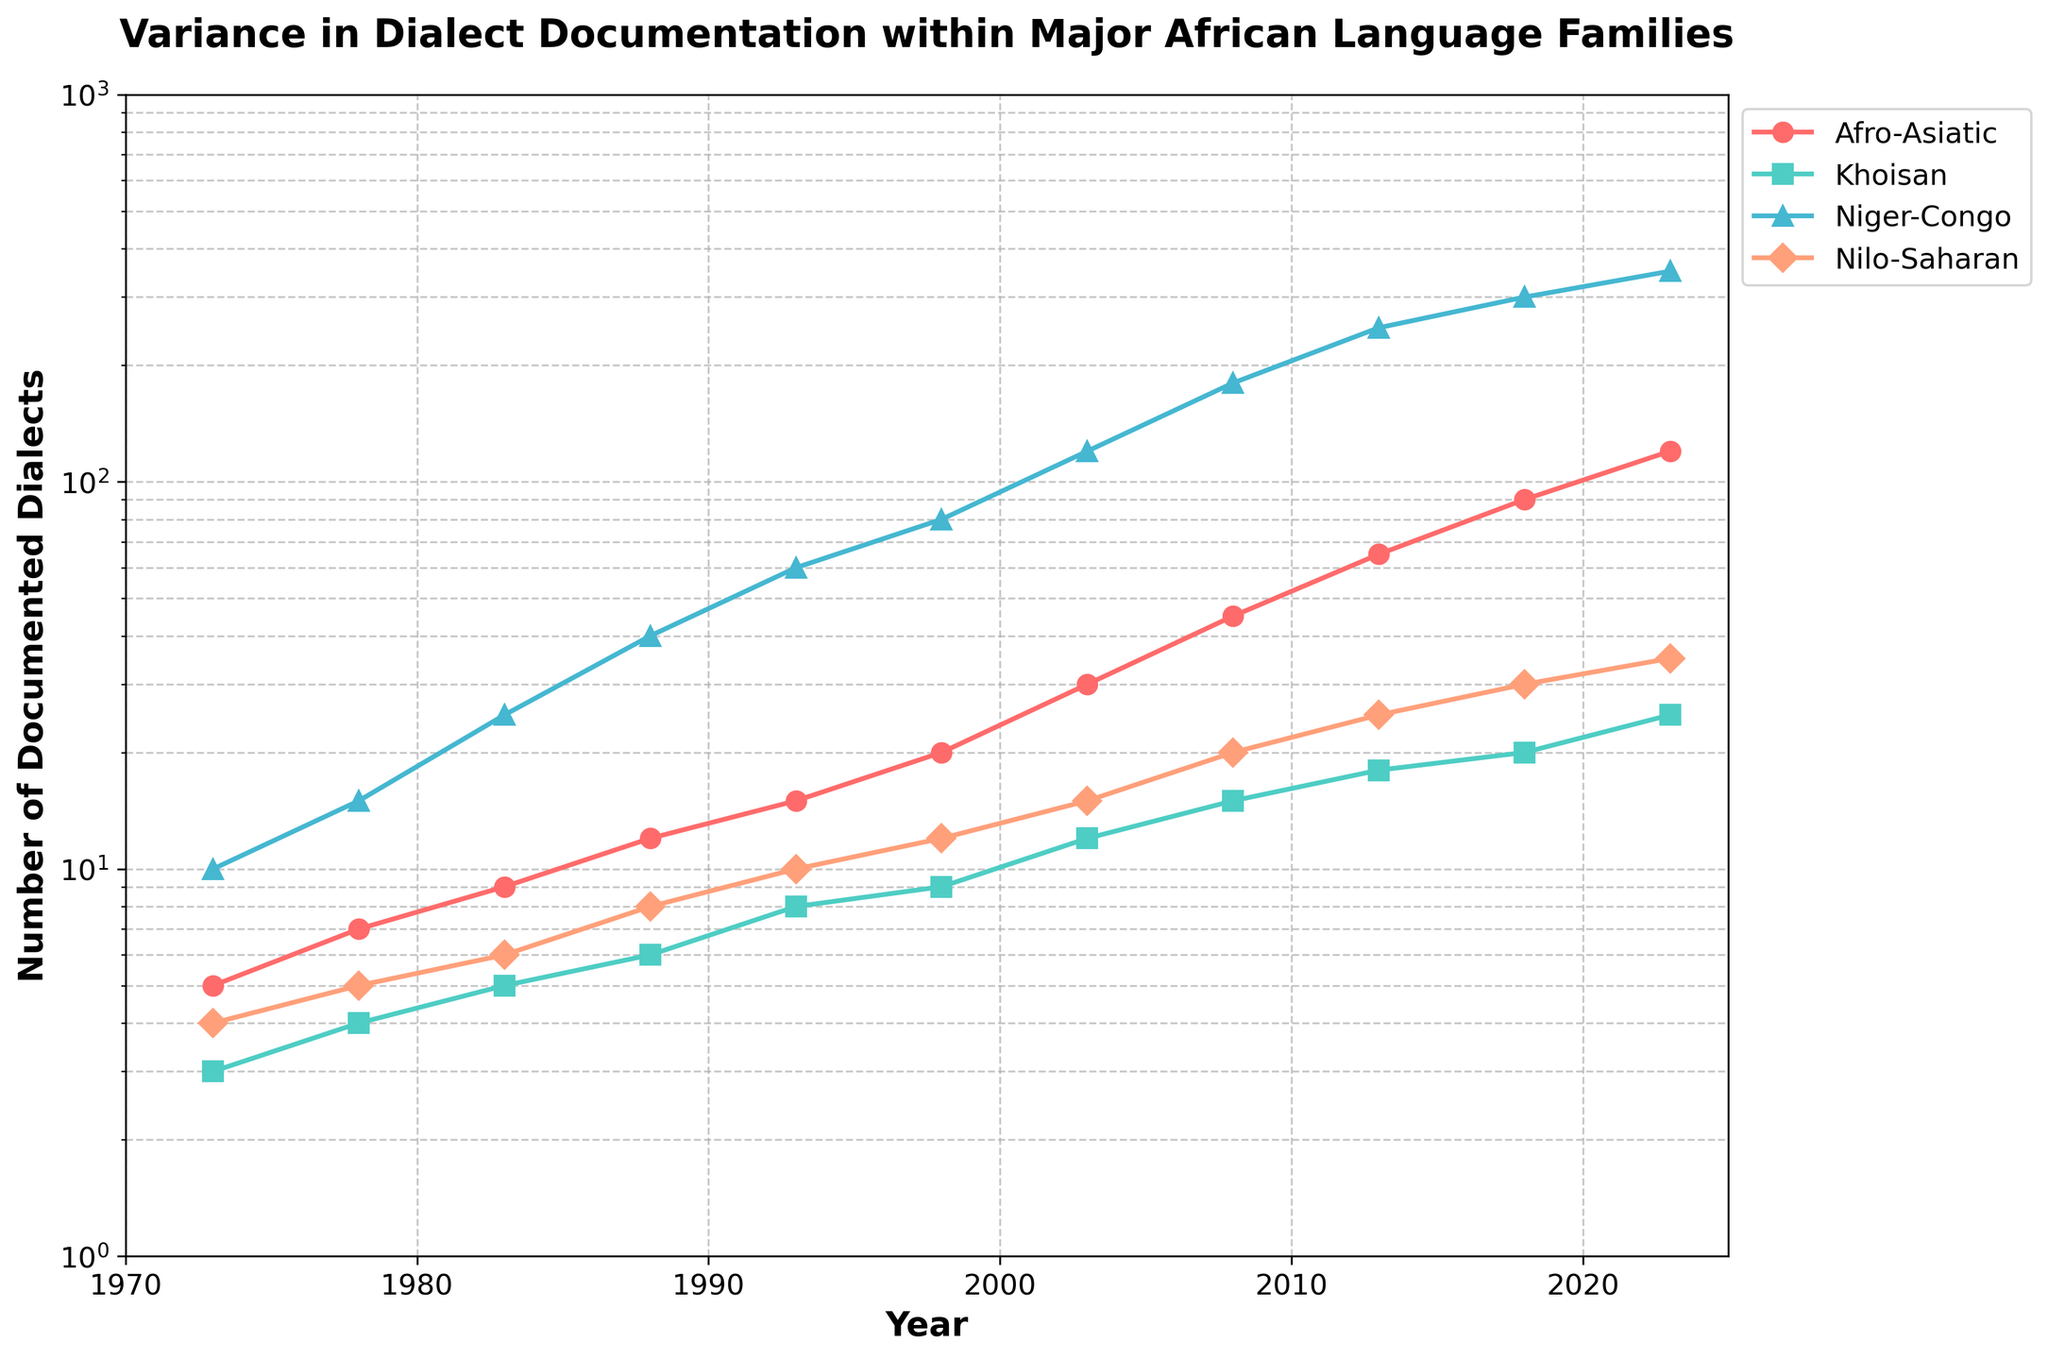What is the title of the figure? The title is displayed at the top center of the figure in bold font.
Answer: Variance in Dialect Documentation within Major African Language Families Which language family had the fewest documented dialects in 1973? By looking at the data points for the year 1973, the dialect counts for each language family are shown. The least documented is Khoisan with 3 dialects.
Answer: Khoisan How many documented dialects did the Niger-Congo family have in 2008? We look at the data point for the Niger-Congo family specifically in the year 2008. The documented dialects count is 180.
Answer: 180 What is the range of documented dialects in the Nilo-Saharan family from 1973 to 2023? The range is found by subtracting the minimum value from the maximum value in the Nilo-Saharan family dataset. From the data, 35 (2023) - 4 (1973) = 31.
Answer: 31 Which language family showed the steepest growth in documented dialects over the 50 years? By examining the slopes of the lines, the Niger-Congo family shows the sharpest increase from 10 in 1973 to 350 in 2023.
Answer: Niger-Congo In what years did the Afro-Asiatic language family have over 50 documented dialects? Checking the data points for the Afro-Asiatic family, the number surpasses 50 starting from the year 2013 onward.
Answer: 2013, 2018, 2023 What is the average number of documented dialects for the Khoisan family every 10 years? Calculating the average across the given years for Khoisan family needs summing all values and dividing by the count. (3+4+5+6+8+9+12+15+18+20+25)/11 = 11.
Answer: 11 Comparing 1988 and 1998, how many more dialects were documented in the Niger-Congo language family? Subtract the 1988 figure from the 1998 figure for Niger-Congo. 80 (1998) - 40 (1988) = 40.
Answer: 40 Which year saw the number of documented dialects in the Nilo-Saharan family double compared to its 1973 count? By observing when the Nilo-Saharan count is twice that of 1973 (4), it is around 1988 (8).
Answer: 1988 